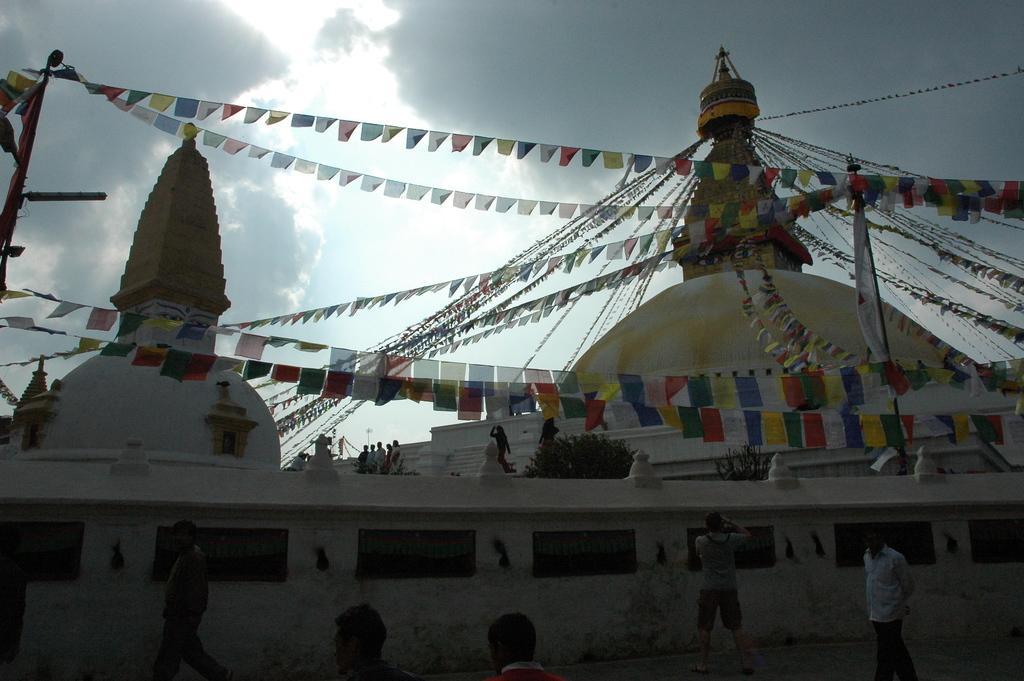Can you describe this image briefly? In this image I can see the buildings decorated with the colorful flags. I can see few people. In the background I can see the clouds and the sky. 